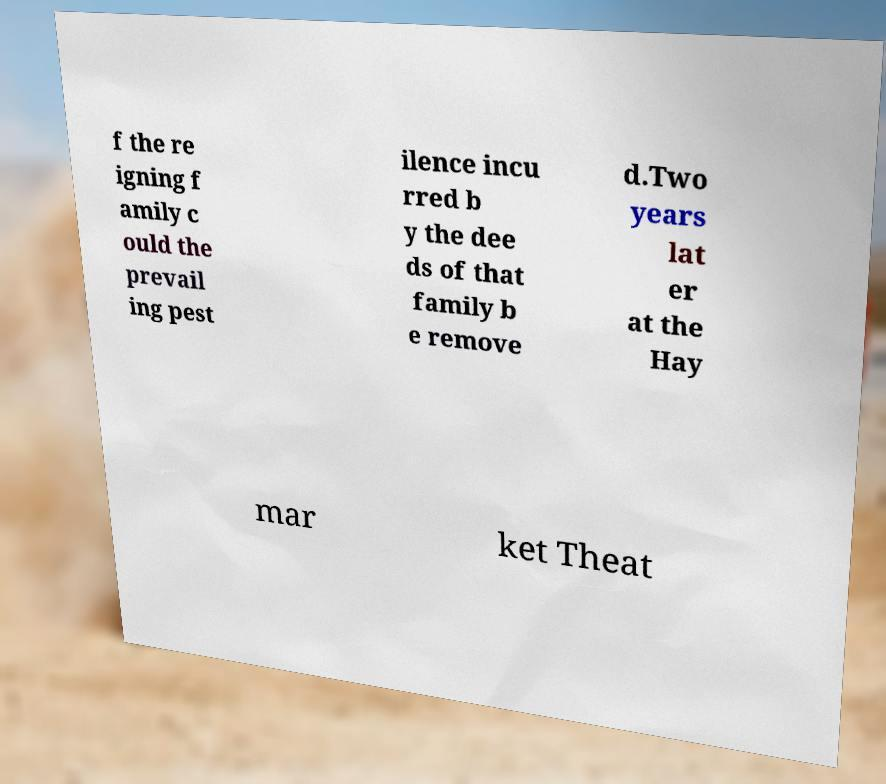Could you extract and type out the text from this image? f the re igning f amily c ould the prevail ing pest ilence incu rred b y the dee ds of that family b e remove d.Two years lat er at the Hay mar ket Theat 